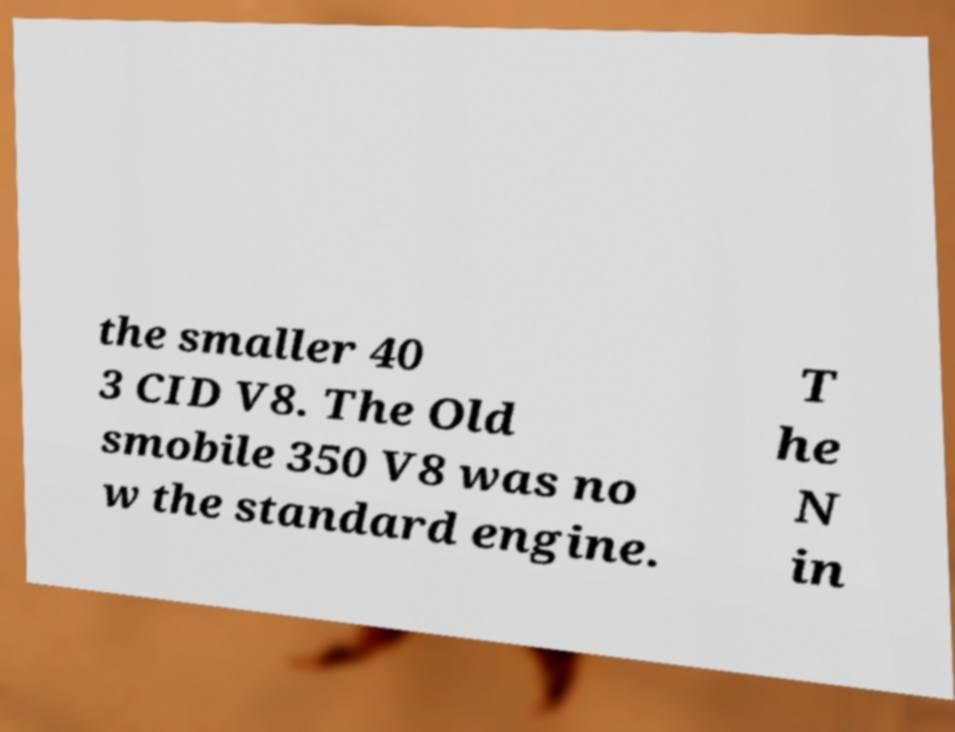Could you assist in decoding the text presented in this image and type it out clearly? the smaller 40 3 CID V8. The Old smobile 350 V8 was no w the standard engine. T he N in 